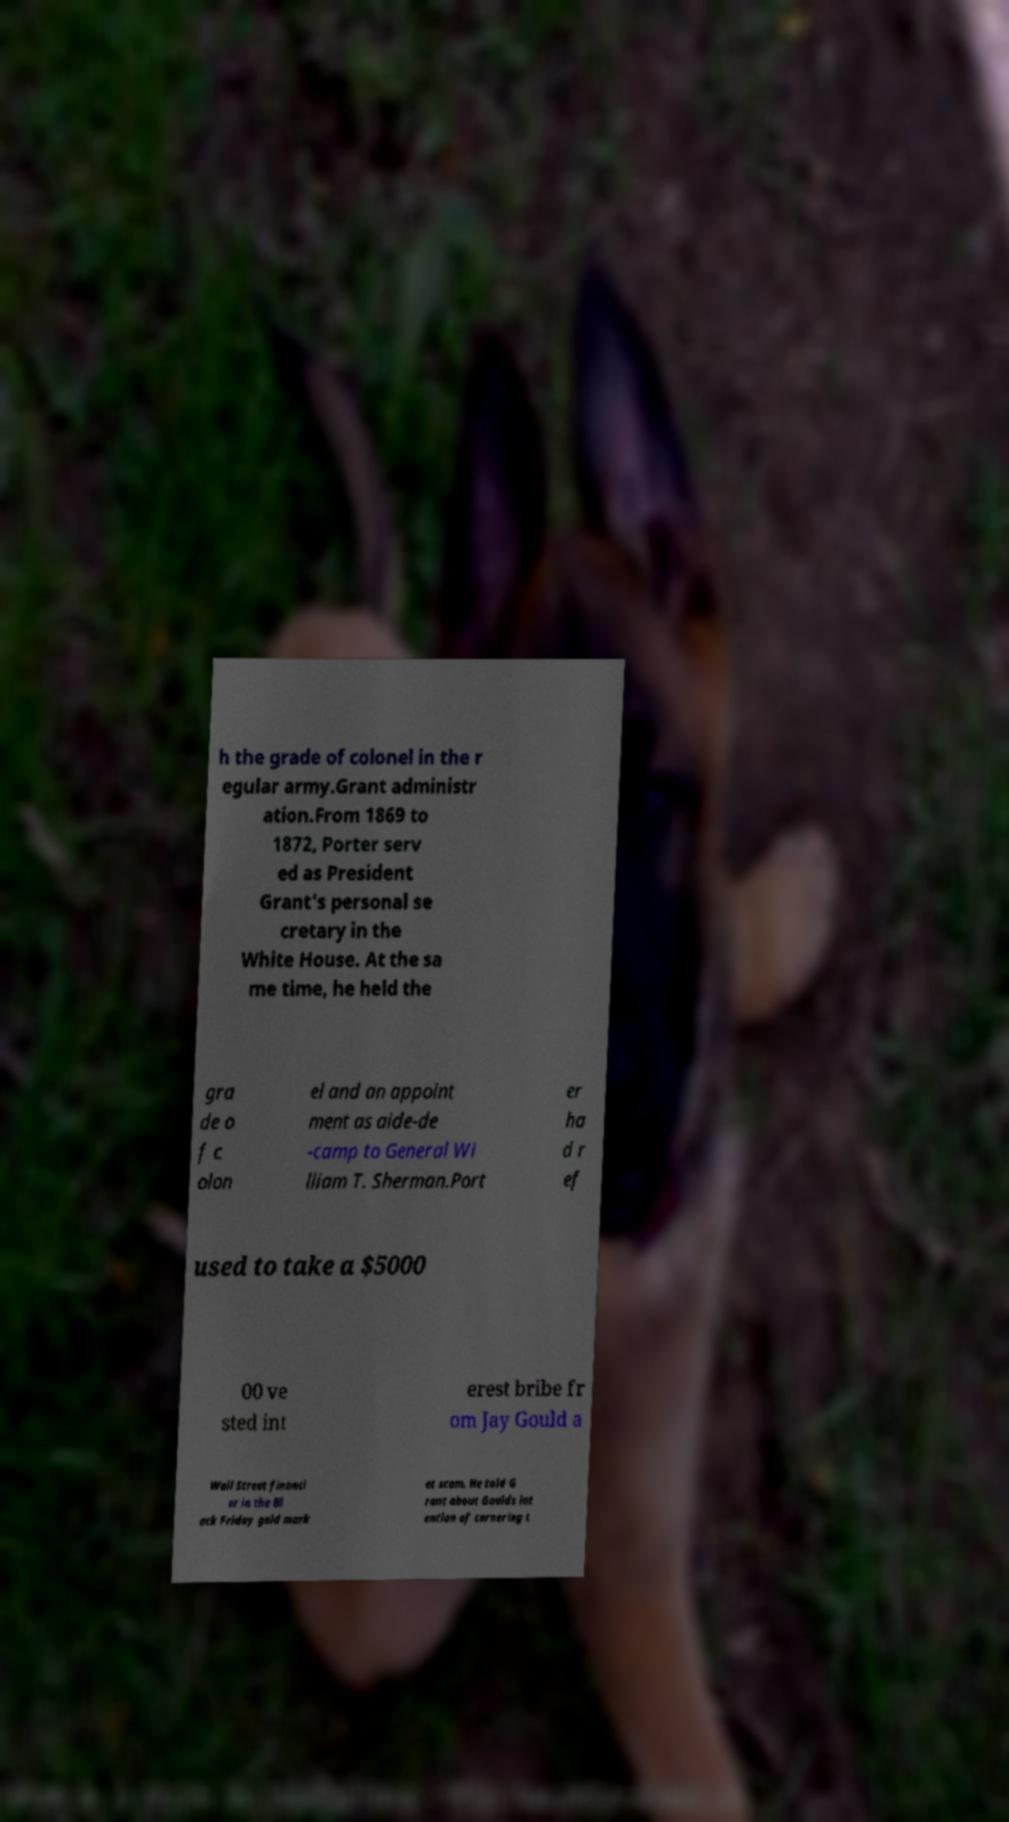What messages or text are displayed in this image? I need them in a readable, typed format. h the grade of colonel in the r egular army.Grant administr ation.From 1869 to 1872, Porter serv ed as President Grant's personal se cretary in the White House. At the sa me time, he held the gra de o f c olon el and an appoint ment as aide-de -camp to General Wi lliam T. Sherman.Port er ha d r ef used to take a $5000 00 ve sted int erest bribe fr om Jay Gould a Wall Street financi er in the Bl ack Friday gold mark et scam. He told G rant about Goulds int ention of cornering t 